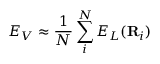<formula> <loc_0><loc_0><loc_500><loc_500>E _ { V } \approx \frac { 1 } { N } \sum _ { i } ^ { N } E _ { L } ( R _ { i } )</formula> 